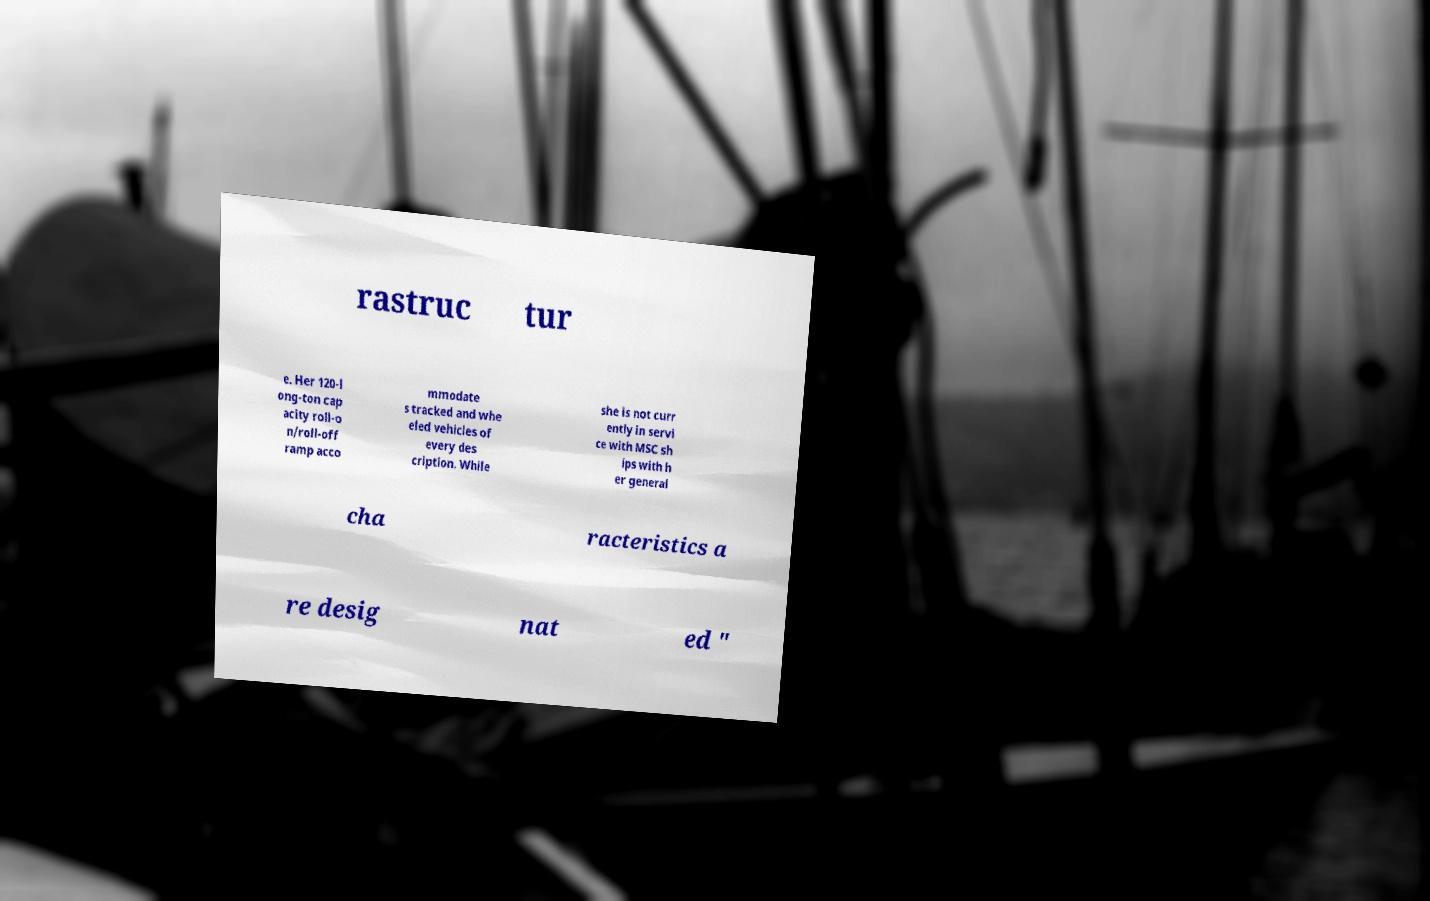Could you extract and type out the text from this image? rastruc tur e. Her 120-l ong-ton cap acity roll-o n/roll-off ramp acco mmodate s tracked and whe eled vehicles of every des cription. While she is not curr ently in servi ce with MSC sh ips with h er general cha racteristics a re desig nat ed " 